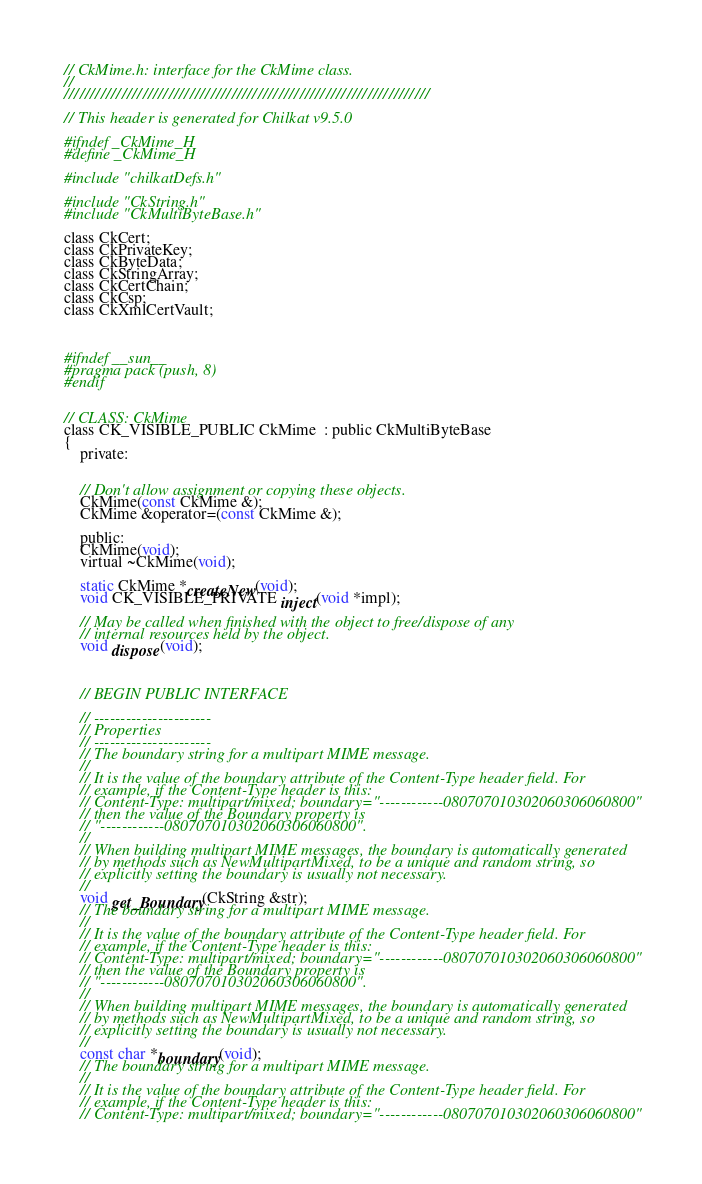Convert code to text. <code><loc_0><loc_0><loc_500><loc_500><_C_>// CkMime.h: interface for the CkMime class.
//
//////////////////////////////////////////////////////////////////////

// This header is generated for Chilkat v9.5.0

#ifndef _CkMime_H
#define _CkMime_H
	
#include "chilkatDefs.h"

#include "CkString.h"
#include "CkMultiByteBase.h"

class CkCert;
class CkPrivateKey;
class CkByteData;
class CkStringArray;
class CkCertChain;
class CkCsp;
class CkXmlCertVault;



#ifndef __sun__
#pragma pack (push, 8)
#endif
 

// CLASS: CkMime
class CK_VISIBLE_PUBLIC CkMime  : public CkMultiByteBase
{
    private:
	

	// Don't allow assignment or copying these objects.
	CkMime(const CkMime &);
	CkMime &operator=(const CkMime &);

    public:
	CkMime(void);
	virtual ~CkMime(void);

	static CkMime *createNew(void);
	void CK_VISIBLE_PRIVATE inject(void *impl);

	// May be called when finished with the object to free/dispose of any
	// internal resources held by the object. 
	void dispose(void);

	

	// BEGIN PUBLIC INTERFACE

	// ----------------------
	// Properties
	// ----------------------
	// The boundary string for a multipart MIME message.
	// 
	// It is the value of the boundary attribute of the Content-Type header field. For
	// example, if the Content-Type header is this:
	// Content-Type: multipart/mixed; boundary="------------080707010302060306060800"
	// then the value of the Boundary property is
	// "------------080707010302060306060800".
	// 
	// When building multipart MIME messages, the boundary is automatically generated
	// by methods such as NewMultipartMixed, to be a unique and random string, so
	// explicitly setting the boundary is usually not necessary.
	// 
	void get_Boundary(CkString &str);
	// The boundary string for a multipart MIME message.
	// 
	// It is the value of the boundary attribute of the Content-Type header field. For
	// example, if the Content-Type header is this:
	// Content-Type: multipart/mixed; boundary="------------080707010302060306060800"
	// then the value of the Boundary property is
	// "------------080707010302060306060800".
	// 
	// When building multipart MIME messages, the boundary is automatically generated
	// by methods such as NewMultipartMixed, to be a unique and random string, so
	// explicitly setting the boundary is usually not necessary.
	// 
	const char *boundary(void);
	// The boundary string for a multipart MIME message.
	// 
	// It is the value of the boundary attribute of the Content-Type header field. For
	// example, if the Content-Type header is this:
	// Content-Type: multipart/mixed; boundary="------------080707010302060306060800"</code> 